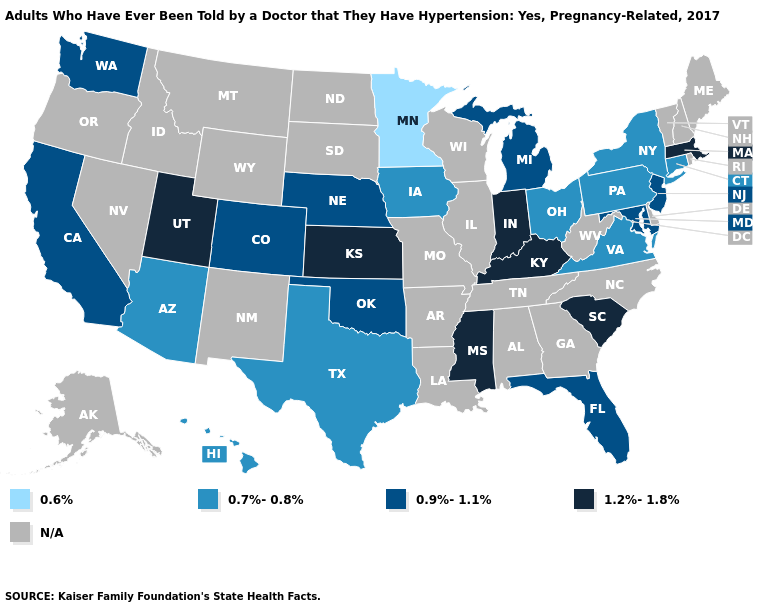What is the lowest value in the West?
Write a very short answer. 0.7%-0.8%. What is the value of California?
Give a very brief answer. 0.9%-1.1%. What is the highest value in the USA?
Keep it brief. 1.2%-1.8%. What is the value of Florida?
Be succinct. 0.9%-1.1%. Name the states that have a value in the range 0.6%?
Be succinct. Minnesota. Does the first symbol in the legend represent the smallest category?
Answer briefly. Yes. Does the map have missing data?
Answer briefly. Yes. Which states have the lowest value in the West?
Keep it brief. Arizona, Hawaii. Which states have the lowest value in the USA?
Answer briefly. Minnesota. Does Michigan have the highest value in the USA?
Concise answer only. No. Among the states that border California , which have the lowest value?
Concise answer only. Arizona. Does Ohio have the lowest value in the USA?
Concise answer only. No. Which states have the lowest value in the USA?
Concise answer only. Minnesota. 